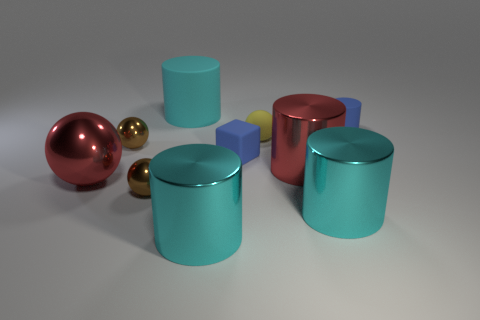Subtract all tiny yellow rubber balls. How many balls are left? 3 Subtract 0 red blocks. How many objects are left? 10 Subtract all cubes. How many objects are left? 9 Subtract 1 cubes. How many cubes are left? 0 Subtract all green balls. Subtract all yellow cubes. How many balls are left? 4 Subtract all blue cylinders. How many yellow spheres are left? 1 Subtract all small purple metal spheres. Subtract all yellow matte objects. How many objects are left? 9 Add 6 yellow things. How many yellow things are left? 7 Add 3 brown metallic balls. How many brown metallic balls exist? 5 Subtract all brown balls. How many balls are left? 2 